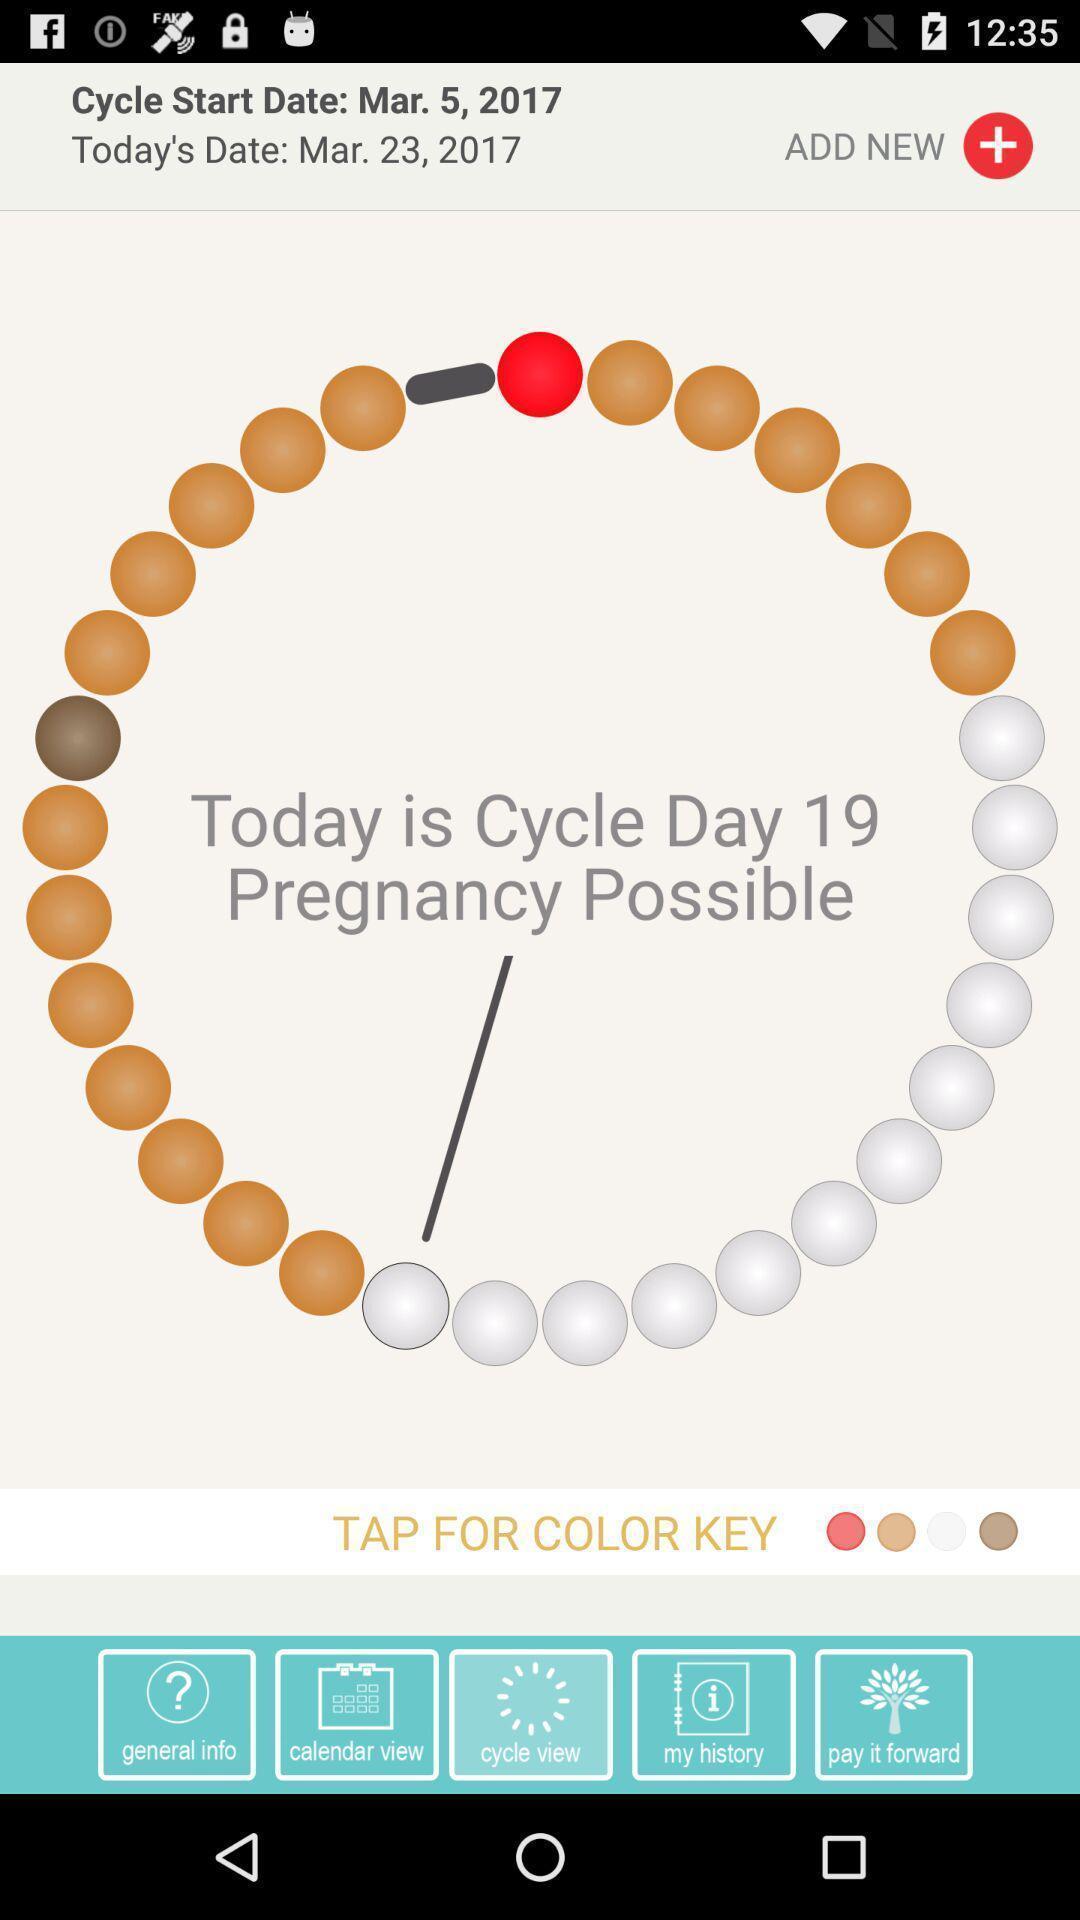Explain the elements present in this screenshot. Screen showing pregnancy cycle view page of a health app. 